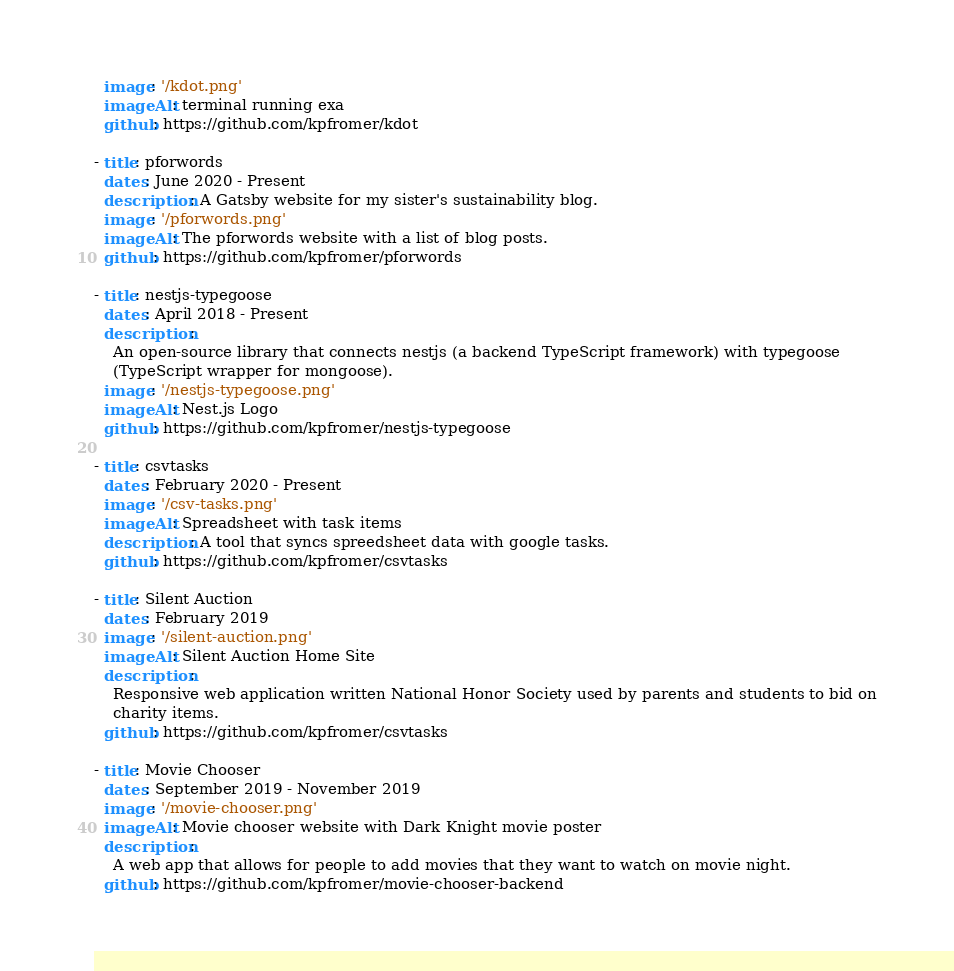Convert code to text. <code><loc_0><loc_0><loc_500><loc_500><_YAML_>  image: '/kdot.png'
  imageAlt: terminal running exa
  github: https://github.com/kpfromer/kdot

- title: pforwords
  dates: June 2020 - Present
  description: A Gatsby website for my sister's sustainability blog.
  image: '/pforwords.png'
  imageAlt: The pforwords website with a list of blog posts.
  github: https://github.com/kpfromer/pforwords

- title: nestjs-typegoose
  dates: April 2018 - Present
  description:
    An open-source library that connects nestjs (a backend TypeScript framework) with typegoose
    (TypeScript wrapper for mongoose).
  image: '/nestjs-typegoose.png'
  imageAlt: Nest.js Logo
  github: https://github.com/kpfromer/nestjs-typegoose

- title: csvtasks
  dates: February 2020 - Present
  image: '/csv-tasks.png'
  imageAlt: Spreadsheet with task items
  description: A tool that syncs spreedsheet data with google tasks.
  github: https://github.com/kpfromer/csvtasks

- title: Silent Auction
  dates: February 2019
  image: '/silent-auction.png'
  imageAlt: Silent Auction Home Site
  description:
    Responsive web application written National Honor Society used by parents and students to bid on
    charity items.
  github: https://github.com/kpfromer/csvtasks

- title: Movie Chooser
  dates: September 2019 - November 2019
  image: '/movie-chooser.png'
  imageAlt: Movie chooser website with Dark Knight movie poster
  description:
    A web app that allows for people to add movies that they want to watch on movie night.
  github: https://github.com/kpfromer/movie-chooser-backend
</code> 